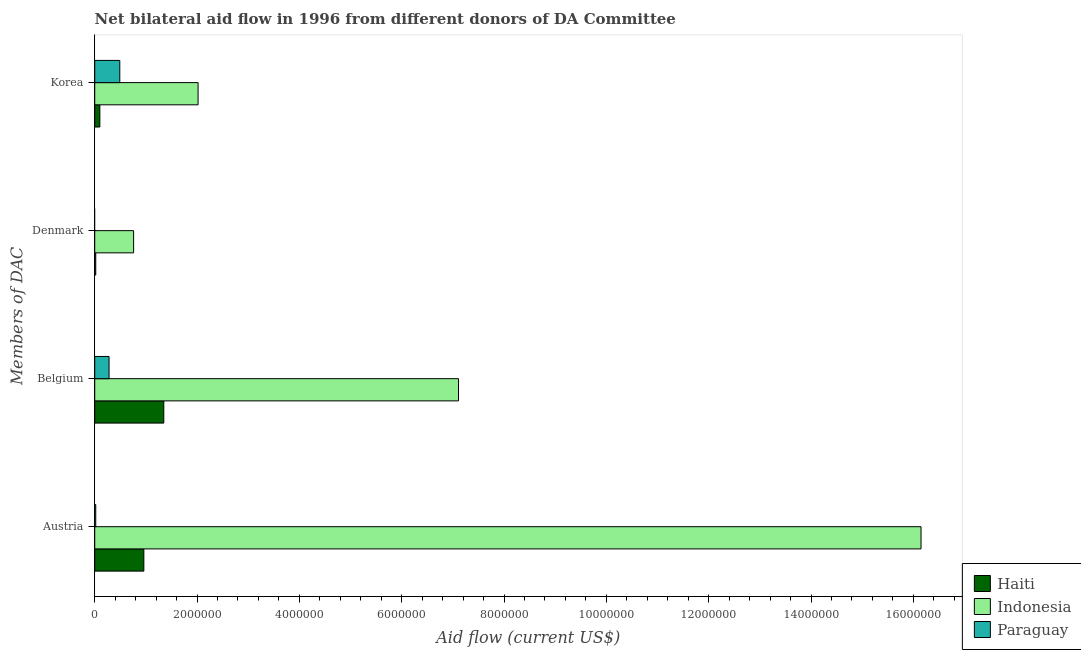How many different coloured bars are there?
Give a very brief answer. 3. How many groups of bars are there?
Your answer should be compact. 4. How many bars are there on the 3rd tick from the top?
Offer a very short reply. 3. What is the label of the 2nd group of bars from the top?
Offer a very short reply. Denmark. What is the amount of aid given by denmark in Haiti?
Keep it short and to the point. 2.00e+04. Across all countries, what is the maximum amount of aid given by austria?
Ensure brevity in your answer.  1.62e+07. Across all countries, what is the minimum amount of aid given by austria?
Provide a short and direct response. 2.00e+04. In which country was the amount of aid given by belgium maximum?
Provide a succinct answer. Indonesia. What is the total amount of aid given by denmark in the graph?
Your answer should be compact. 7.80e+05. What is the difference between the amount of aid given by belgium in Indonesia and that in Paraguay?
Provide a succinct answer. 6.83e+06. What is the difference between the amount of aid given by austria in Haiti and the amount of aid given by denmark in Indonesia?
Give a very brief answer. 2.00e+05. What is the average amount of aid given by korea per country?
Make the answer very short. 8.70e+05. What is the difference between the amount of aid given by korea and amount of aid given by denmark in Haiti?
Provide a short and direct response. 8.00e+04. In how many countries, is the amount of aid given by austria greater than 11200000 US$?
Give a very brief answer. 1. What is the ratio of the amount of aid given by belgium in Indonesia to that in Haiti?
Provide a short and direct response. 5.27. Is the difference between the amount of aid given by korea in Haiti and Indonesia greater than the difference between the amount of aid given by denmark in Haiti and Indonesia?
Give a very brief answer. No. What is the difference between the highest and the second highest amount of aid given by austria?
Give a very brief answer. 1.52e+07. What is the difference between the highest and the lowest amount of aid given by denmark?
Keep it short and to the point. 7.60e+05. How many bars are there?
Make the answer very short. 11. Are all the bars in the graph horizontal?
Give a very brief answer. Yes. How many countries are there in the graph?
Your answer should be very brief. 3. What is the title of the graph?
Give a very brief answer. Net bilateral aid flow in 1996 from different donors of DA Committee. What is the label or title of the Y-axis?
Keep it short and to the point. Members of DAC. What is the Aid flow (current US$) in Haiti in Austria?
Keep it short and to the point. 9.60e+05. What is the Aid flow (current US$) of Indonesia in Austria?
Your answer should be compact. 1.62e+07. What is the Aid flow (current US$) of Paraguay in Austria?
Provide a succinct answer. 2.00e+04. What is the Aid flow (current US$) of Haiti in Belgium?
Your response must be concise. 1.35e+06. What is the Aid flow (current US$) in Indonesia in Belgium?
Keep it short and to the point. 7.11e+06. What is the Aid flow (current US$) of Haiti in Denmark?
Keep it short and to the point. 2.00e+04. What is the Aid flow (current US$) in Indonesia in Denmark?
Give a very brief answer. 7.60e+05. What is the Aid flow (current US$) in Paraguay in Denmark?
Your response must be concise. 0. What is the Aid flow (current US$) in Haiti in Korea?
Keep it short and to the point. 1.00e+05. What is the Aid flow (current US$) of Indonesia in Korea?
Provide a short and direct response. 2.02e+06. Across all Members of DAC, what is the maximum Aid flow (current US$) of Haiti?
Ensure brevity in your answer.  1.35e+06. Across all Members of DAC, what is the maximum Aid flow (current US$) in Indonesia?
Provide a short and direct response. 1.62e+07. Across all Members of DAC, what is the minimum Aid flow (current US$) in Indonesia?
Provide a succinct answer. 7.60e+05. What is the total Aid flow (current US$) of Haiti in the graph?
Offer a terse response. 2.43e+06. What is the total Aid flow (current US$) in Indonesia in the graph?
Your response must be concise. 2.60e+07. What is the total Aid flow (current US$) in Paraguay in the graph?
Make the answer very short. 7.90e+05. What is the difference between the Aid flow (current US$) of Haiti in Austria and that in Belgium?
Your answer should be very brief. -3.90e+05. What is the difference between the Aid flow (current US$) of Indonesia in Austria and that in Belgium?
Your response must be concise. 9.04e+06. What is the difference between the Aid flow (current US$) in Haiti in Austria and that in Denmark?
Your answer should be very brief. 9.40e+05. What is the difference between the Aid flow (current US$) in Indonesia in Austria and that in Denmark?
Offer a very short reply. 1.54e+07. What is the difference between the Aid flow (current US$) in Haiti in Austria and that in Korea?
Ensure brevity in your answer.  8.60e+05. What is the difference between the Aid flow (current US$) of Indonesia in Austria and that in Korea?
Offer a very short reply. 1.41e+07. What is the difference between the Aid flow (current US$) of Paraguay in Austria and that in Korea?
Keep it short and to the point. -4.70e+05. What is the difference between the Aid flow (current US$) of Haiti in Belgium and that in Denmark?
Offer a very short reply. 1.33e+06. What is the difference between the Aid flow (current US$) of Indonesia in Belgium and that in Denmark?
Provide a short and direct response. 6.35e+06. What is the difference between the Aid flow (current US$) of Haiti in Belgium and that in Korea?
Offer a very short reply. 1.25e+06. What is the difference between the Aid flow (current US$) in Indonesia in Belgium and that in Korea?
Your answer should be compact. 5.09e+06. What is the difference between the Aid flow (current US$) in Paraguay in Belgium and that in Korea?
Give a very brief answer. -2.10e+05. What is the difference between the Aid flow (current US$) in Indonesia in Denmark and that in Korea?
Give a very brief answer. -1.26e+06. What is the difference between the Aid flow (current US$) of Haiti in Austria and the Aid flow (current US$) of Indonesia in Belgium?
Make the answer very short. -6.15e+06. What is the difference between the Aid flow (current US$) of Haiti in Austria and the Aid flow (current US$) of Paraguay in Belgium?
Your answer should be very brief. 6.80e+05. What is the difference between the Aid flow (current US$) of Indonesia in Austria and the Aid flow (current US$) of Paraguay in Belgium?
Your response must be concise. 1.59e+07. What is the difference between the Aid flow (current US$) of Haiti in Austria and the Aid flow (current US$) of Indonesia in Korea?
Your response must be concise. -1.06e+06. What is the difference between the Aid flow (current US$) in Haiti in Austria and the Aid flow (current US$) in Paraguay in Korea?
Provide a succinct answer. 4.70e+05. What is the difference between the Aid flow (current US$) in Indonesia in Austria and the Aid flow (current US$) in Paraguay in Korea?
Offer a very short reply. 1.57e+07. What is the difference between the Aid flow (current US$) of Haiti in Belgium and the Aid flow (current US$) of Indonesia in Denmark?
Offer a terse response. 5.90e+05. What is the difference between the Aid flow (current US$) in Haiti in Belgium and the Aid flow (current US$) in Indonesia in Korea?
Give a very brief answer. -6.70e+05. What is the difference between the Aid flow (current US$) of Haiti in Belgium and the Aid flow (current US$) of Paraguay in Korea?
Offer a very short reply. 8.60e+05. What is the difference between the Aid flow (current US$) of Indonesia in Belgium and the Aid flow (current US$) of Paraguay in Korea?
Your response must be concise. 6.62e+06. What is the difference between the Aid flow (current US$) of Haiti in Denmark and the Aid flow (current US$) of Paraguay in Korea?
Give a very brief answer. -4.70e+05. What is the difference between the Aid flow (current US$) of Indonesia in Denmark and the Aid flow (current US$) of Paraguay in Korea?
Your response must be concise. 2.70e+05. What is the average Aid flow (current US$) in Haiti per Members of DAC?
Offer a very short reply. 6.08e+05. What is the average Aid flow (current US$) in Indonesia per Members of DAC?
Provide a short and direct response. 6.51e+06. What is the average Aid flow (current US$) of Paraguay per Members of DAC?
Your answer should be very brief. 1.98e+05. What is the difference between the Aid flow (current US$) of Haiti and Aid flow (current US$) of Indonesia in Austria?
Your response must be concise. -1.52e+07. What is the difference between the Aid flow (current US$) of Haiti and Aid flow (current US$) of Paraguay in Austria?
Give a very brief answer. 9.40e+05. What is the difference between the Aid flow (current US$) of Indonesia and Aid flow (current US$) of Paraguay in Austria?
Keep it short and to the point. 1.61e+07. What is the difference between the Aid flow (current US$) of Haiti and Aid flow (current US$) of Indonesia in Belgium?
Your answer should be compact. -5.76e+06. What is the difference between the Aid flow (current US$) in Haiti and Aid flow (current US$) in Paraguay in Belgium?
Provide a succinct answer. 1.07e+06. What is the difference between the Aid flow (current US$) of Indonesia and Aid flow (current US$) of Paraguay in Belgium?
Keep it short and to the point. 6.83e+06. What is the difference between the Aid flow (current US$) in Haiti and Aid flow (current US$) in Indonesia in Denmark?
Offer a very short reply. -7.40e+05. What is the difference between the Aid flow (current US$) in Haiti and Aid flow (current US$) in Indonesia in Korea?
Your answer should be compact. -1.92e+06. What is the difference between the Aid flow (current US$) of Haiti and Aid flow (current US$) of Paraguay in Korea?
Ensure brevity in your answer.  -3.90e+05. What is the difference between the Aid flow (current US$) in Indonesia and Aid flow (current US$) in Paraguay in Korea?
Keep it short and to the point. 1.53e+06. What is the ratio of the Aid flow (current US$) in Haiti in Austria to that in Belgium?
Provide a short and direct response. 0.71. What is the ratio of the Aid flow (current US$) in Indonesia in Austria to that in Belgium?
Your answer should be very brief. 2.27. What is the ratio of the Aid flow (current US$) of Paraguay in Austria to that in Belgium?
Your answer should be very brief. 0.07. What is the ratio of the Aid flow (current US$) in Haiti in Austria to that in Denmark?
Offer a terse response. 48. What is the ratio of the Aid flow (current US$) of Indonesia in Austria to that in Denmark?
Provide a short and direct response. 21.25. What is the ratio of the Aid flow (current US$) of Indonesia in Austria to that in Korea?
Give a very brief answer. 8. What is the ratio of the Aid flow (current US$) in Paraguay in Austria to that in Korea?
Provide a succinct answer. 0.04. What is the ratio of the Aid flow (current US$) of Haiti in Belgium to that in Denmark?
Offer a very short reply. 67.5. What is the ratio of the Aid flow (current US$) of Indonesia in Belgium to that in Denmark?
Provide a succinct answer. 9.36. What is the ratio of the Aid flow (current US$) of Haiti in Belgium to that in Korea?
Your answer should be very brief. 13.5. What is the ratio of the Aid flow (current US$) of Indonesia in Belgium to that in Korea?
Provide a succinct answer. 3.52. What is the ratio of the Aid flow (current US$) in Paraguay in Belgium to that in Korea?
Provide a short and direct response. 0.57. What is the ratio of the Aid flow (current US$) in Haiti in Denmark to that in Korea?
Provide a short and direct response. 0.2. What is the ratio of the Aid flow (current US$) of Indonesia in Denmark to that in Korea?
Provide a short and direct response. 0.38. What is the difference between the highest and the second highest Aid flow (current US$) of Indonesia?
Give a very brief answer. 9.04e+06. What is the difference between the highest and the second highest Aid flow (current US$) in Paraguay?
Your answer should be very brief. 2.10e+05. What is the difference between the highest and the lowest Aid flow (current US$) of Haiti?
Provide a short and direct response. 1.33e+06. What is the difference between the highest and the lowest Aid flow (current US$) of Indonesia?
Make the answer very short. 1.54e+07. What is the difference between the highest and the lowest Aid flow (current US$) of Paraguay?
Your answer should be compact. 4.90e+05. 